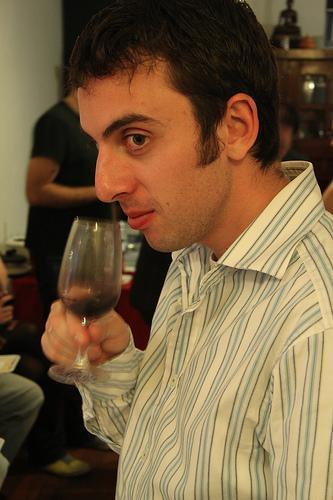How many glasses are there?
Give a very brief answer. 1. How many people are there?
Give a very brief answer. 3. How many people are wearing a black shirt?
Give a very brief answer. 1. 